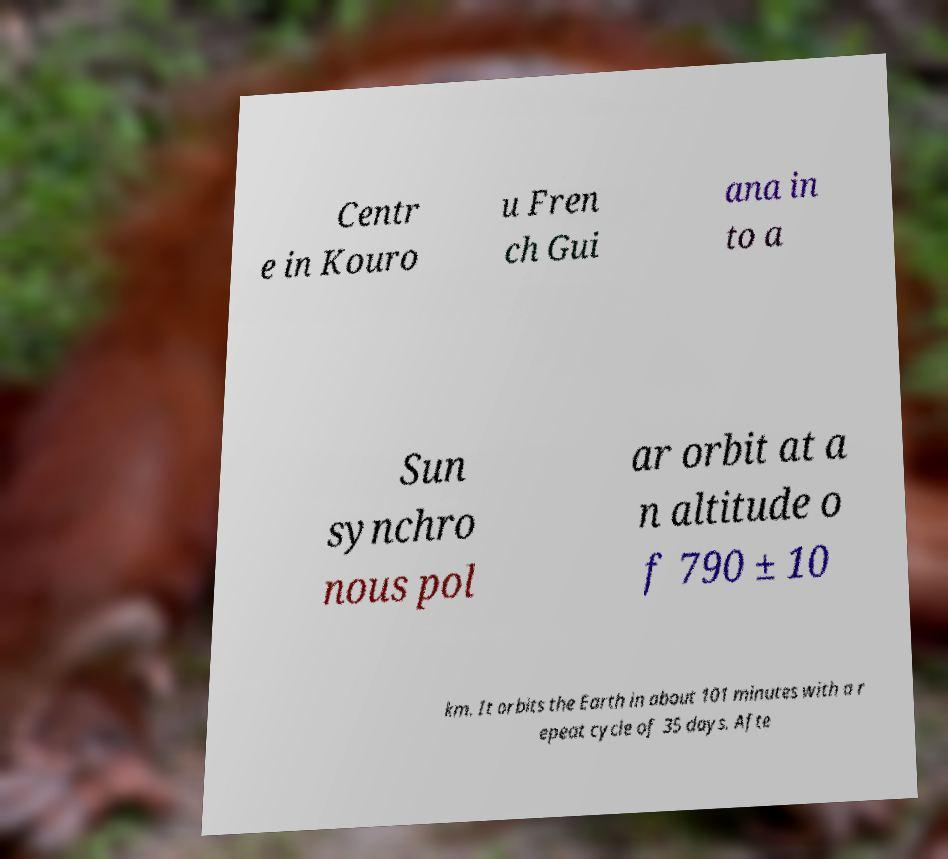Could you extract and type out the text from this image? Centr e in Kouro u Fren ch Gui ana in to a Sun synchro nous pol ar orbit at a n altitude o f 790 ± 10 km. It orbits the Earth in about 101 minutes with a r epeat cycle of 35 days. Afte 